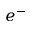<formula> <loc_0><loc_0><loc_500><loc_500>e ^ { - }</formula> 